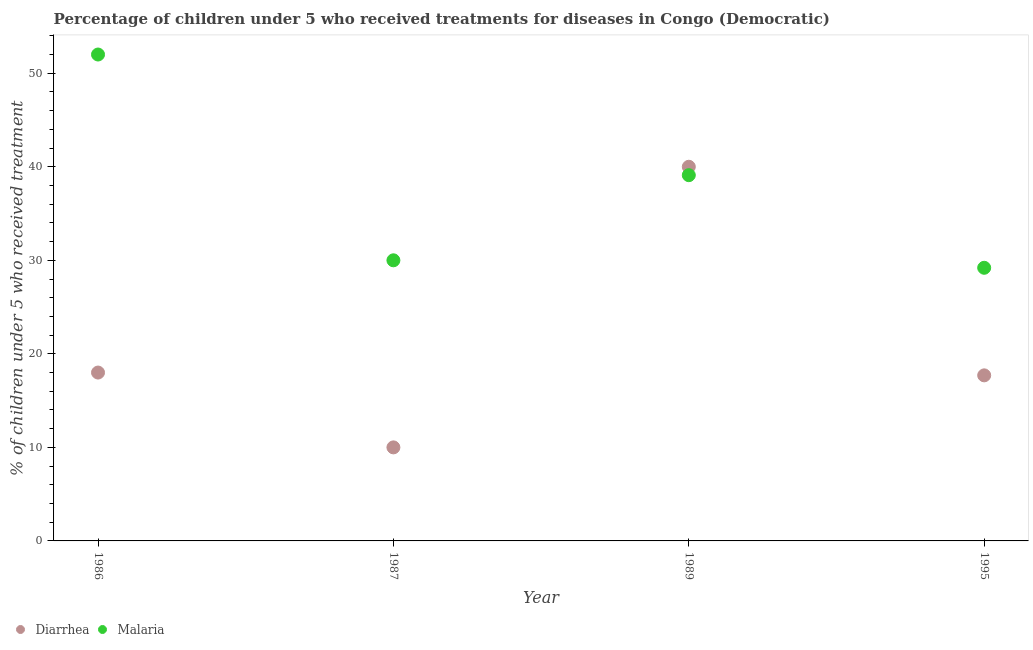Is the number of dotlines equal to the number of legend labels?
Make the answer very short. Yes. What is the percentage of children who received treatment for malaria in 1995?
Your response must be concise. 29.2. Across all years, what is the minimum percentage of children who received treatment for malaria?
Provide a short and direct response. 29.2. In which year was the percentage of children who received treatment for malaria maximum?
Your response must be concise. 1986. What is the total percentage of children who received treatment for diarrhoea in the graph?
Your answer should be compact. 85.7. What is the difference between the percentage of children who received treatment for malaria in 1987 and that in 1995?
Ensure brevity in your answer.  0.8. What is the difference between the percentage of children who received treatment for malaria in 1989 and the percentage of children who received treatment for diarrhoea in 1986?
Ensure brevity in your answer.  21.1. What is the average percentage of children who received treatment for malaria per year?
Offer a very short reply. 37.57. In the year 1986, what is the difference between the percentage of children who received treatment for diarrhoea and percentage of children who received treatment for malaria?
Provide a short and direct response. -34. In how many years, is the percentage of children who received treatment for diarrhoea greater than 6 %?
Make the answer very short. 4. What is the ratio of the percentage of children who received treatment for malaria in 1986 to that in 1989?
Provide a short and direct response. 1.33. Is the percentage of children who received treatment for malaria in 1989 less than that in 1995?
Your response must be concise. No. Is the difference between the percentage of children who received treatment for diarrhoea in 1986 and 1989 greater than the difference between the percentage of children who received treatment for malaria in 1986 and 1989?
Provide a succinct answer. No. What is the difference between the highest and the second highest percentage of children who received treatment for malaria?
Give a very brief answer. 12.9. Does the percentage of children who received treatment for malaria monotonically increase over the years?
Your response must be concise. No. Is the percentage of children who received treatment for malaria strictly greater than the percentage of children who received treatment for diarrhoea over the years?
Offer a terse response. No. How many dotlines are there?
Make the answer very short. 2. How many years are there in the graph?
Ensure brevity in your answer.  4. What is the difference between two consecutive major ticks on the Y-axis?
Keep it short and to the point. 10. How many legend labels are there?
Provide a succinct answer. 2. What is the title of the graph?
Offer a terse response. Percentage of children under 5 who received treatments for diseases in Congo (Democratic). Does "Largest city" appear as one of the legend labels in the graph?
Give a very brief answer. No. What is the label or title of the X-axis?
Ensure brevity in your answer.  Year. What is the label or title of the Y-axis?
Offer a very short reply. % of children under 5 who received treatment. What is the % of children under 5 who received treatment in Diarrhea in 1986?
Your answer should be very brief. 18. What is the % of children under 5 who received treatment in Malaria in 1989?
Provide a succinct answer. 39.1. What is the % of children under 5 who received treatment of Diarrhea in 1995?
Offer a very short reply. 17.7. What is the % of children under 5 who received treatment of Malaria in 1995?
Your answer should be very brief. 29.2. Across all years, what is the minimum % of children under 5 who received treatment of Diarrhea?
Offer a terse response. 10. Across all years, what is the minimum % of children under 5 who received treatment in Malaria?
Keep it short and to the point. 29.2. What is the total % of children under 5 who received treatment of Diarrhea in the graph?
Keep it short and to the point. 85.7. What is the total % of children under 5 who received treatment of Malaria in the graph?
Provide a succinct answer. 150.3. What is the difference between the % of children under 5 who received treatment in Malaria in 1986 and that in 1989?
Offer a terse response. 12.9. What is the difference between the % of children under 5 who received treatment in Malaria in 1986 and that in 1995?
Keep it short and to the point. 22.8. What is the difference between the % of children under 5 who received treatment in Diarrhea in 1987 and that in 1989?
Your response must be concise. -30. What is the difference between the % of children under 5 who received treatment in Diarrhea in 1987 and that in 1995?
Offer a terse response. -7.7. What is the difference between the % of children under 5 who received treatment in Diarrhea in 1989 and that in 1995?
Offer a very short reply. 22.3. What is the difference between the % of children under 5 who received treatment of Diarrhea in 1986 and the % of children under 5 who received treatment of Malaria in 1987?
Keep it short and to the point. -12. What is the difference between the % of children under 5 who received treatment in Diarrhea in 1986 and the % of children under 5 who received treatment in Malaria in 1989?
Provide a short and direct response. -21.1. What is the difference between the % of children under 5 who received treatment in Diarrhea in 1987 and the % of children under 5 who received treatment in Malaria in 1989?
Offer a very short reply. -29.1. What is the difference between the % of children under 5 who received treatment in Diarrhea in 1987 and the % of children under 5 who received treatment in Malaria in 1995?
Offer a terse response. -19.2. What is the average % of children under 5 who received treatment in Diarrhea per year?
Give a very brief answer. 21.43. What is the average % of children under 5 who received treatment of Malaria per year?
Offer a very short reply. 37.58. In the year 1986, what is the difference between the % of children under 5 who received treatment of Diarrhea and % of children under 5 who received treatment of Malaria?
Offer a terse response. -34. In the year 1987, what is the difference between the % of children under 5 who received treatment in Diarrhea and % of children under 5 who received treatment in Malaria?
Offer a very short reply. -20. In the year 1989, what is the difference between the % of children under 5 who received treatment of Diarrhea and % of children under 5 who received treatment of Malaria?
Ensure brevity in your answer.  0.9. What is the ratio of the % of children under 5 who received treatment of Diarrhea in 1986 to that in 1987?
Your response must be concise. 1.8. What is the ratio of the % of children under 5 who received treatment in Malaria in 1986 to that in 1987?
Keep it short and to the point. 1.73. What is the ratio of the % of children under 5 who received treatment of Diarrhea in 1986 to that in 1989?
Your answer should be compact. 0.45. What is the ratio of the % of children under 5 who received treatment in Malaria in 1986 to that in 1989?
Offer a very short reply. 1.33. What is the ratio of the % of children under 5 who received treatment of Diarrhea in 1986 to that in 1995?
Keep it short and to the point. 1.02. What is the ratio of the % of children under 5 who received treatment of Malaria in 1986 to that in 1995?
Offer a terse response. 1.78. What is the ratio of the % of children under 5 who received treatment of Diarrhea in 1987 to that in 1989?
Give a very brief answer. 0.25. What is the ratio of the % of children under 5 who received treatment in Malaria in 1987 to that in 1989?
Your answer should be very brief. 0.77. What is the ratio of the % of children under 5 who received treatment in Diarrhea in 1987 to that in 1995?
Provide a short and direct response. 0.56. What is the ratio of the % of children under 5 who received treatment in Malaria in 1987 to that in 1995?
Your response must be concise. 1.03. What is the ratio of the % of children under 5 who received treatment of Diarrhea in 1989 to that in 1995?
Provide a short and direct response. 2.26. What is the ratio of the % of children under 5 who received treatment in Malaria in 1989 to that in 1995?
Your response must be concise. 1.34. What is the difference between the highest and the second highest % of children under 5 who received treatment of Malaria?
Ensure brevity in your answer.  12.9. What is the difference between the highest and the lowest % of children under 5 who received treatment of Diarrhea?
Offer a very short reply. 30. What is the difference between the highest and the lowest % of children under 5 who received treatment in Malaria?
Offer a very short reply. 22.8. 